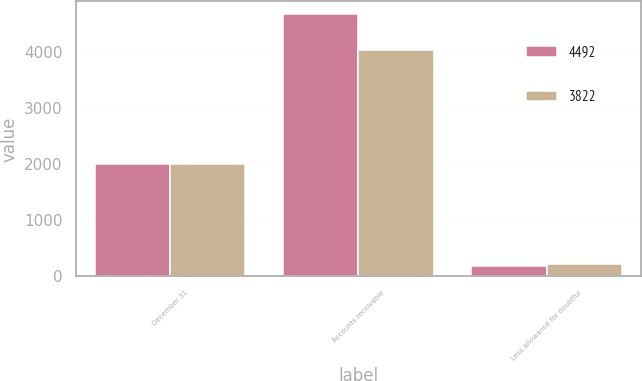Convert chart to OTSL. <chart><loc_0><loc_0><loc_500><loc_500><stacked_bar_chart><ecel><fcel>December 31<fcel>Accounts receivable<fcel>Less allowance for doubtful<nl><fcel>4492<fcel>2004<fcel>4674<fcel>182<nl><fcel>3822<fcel>2003<fcel>4046<fcel>224<nl></chart> 